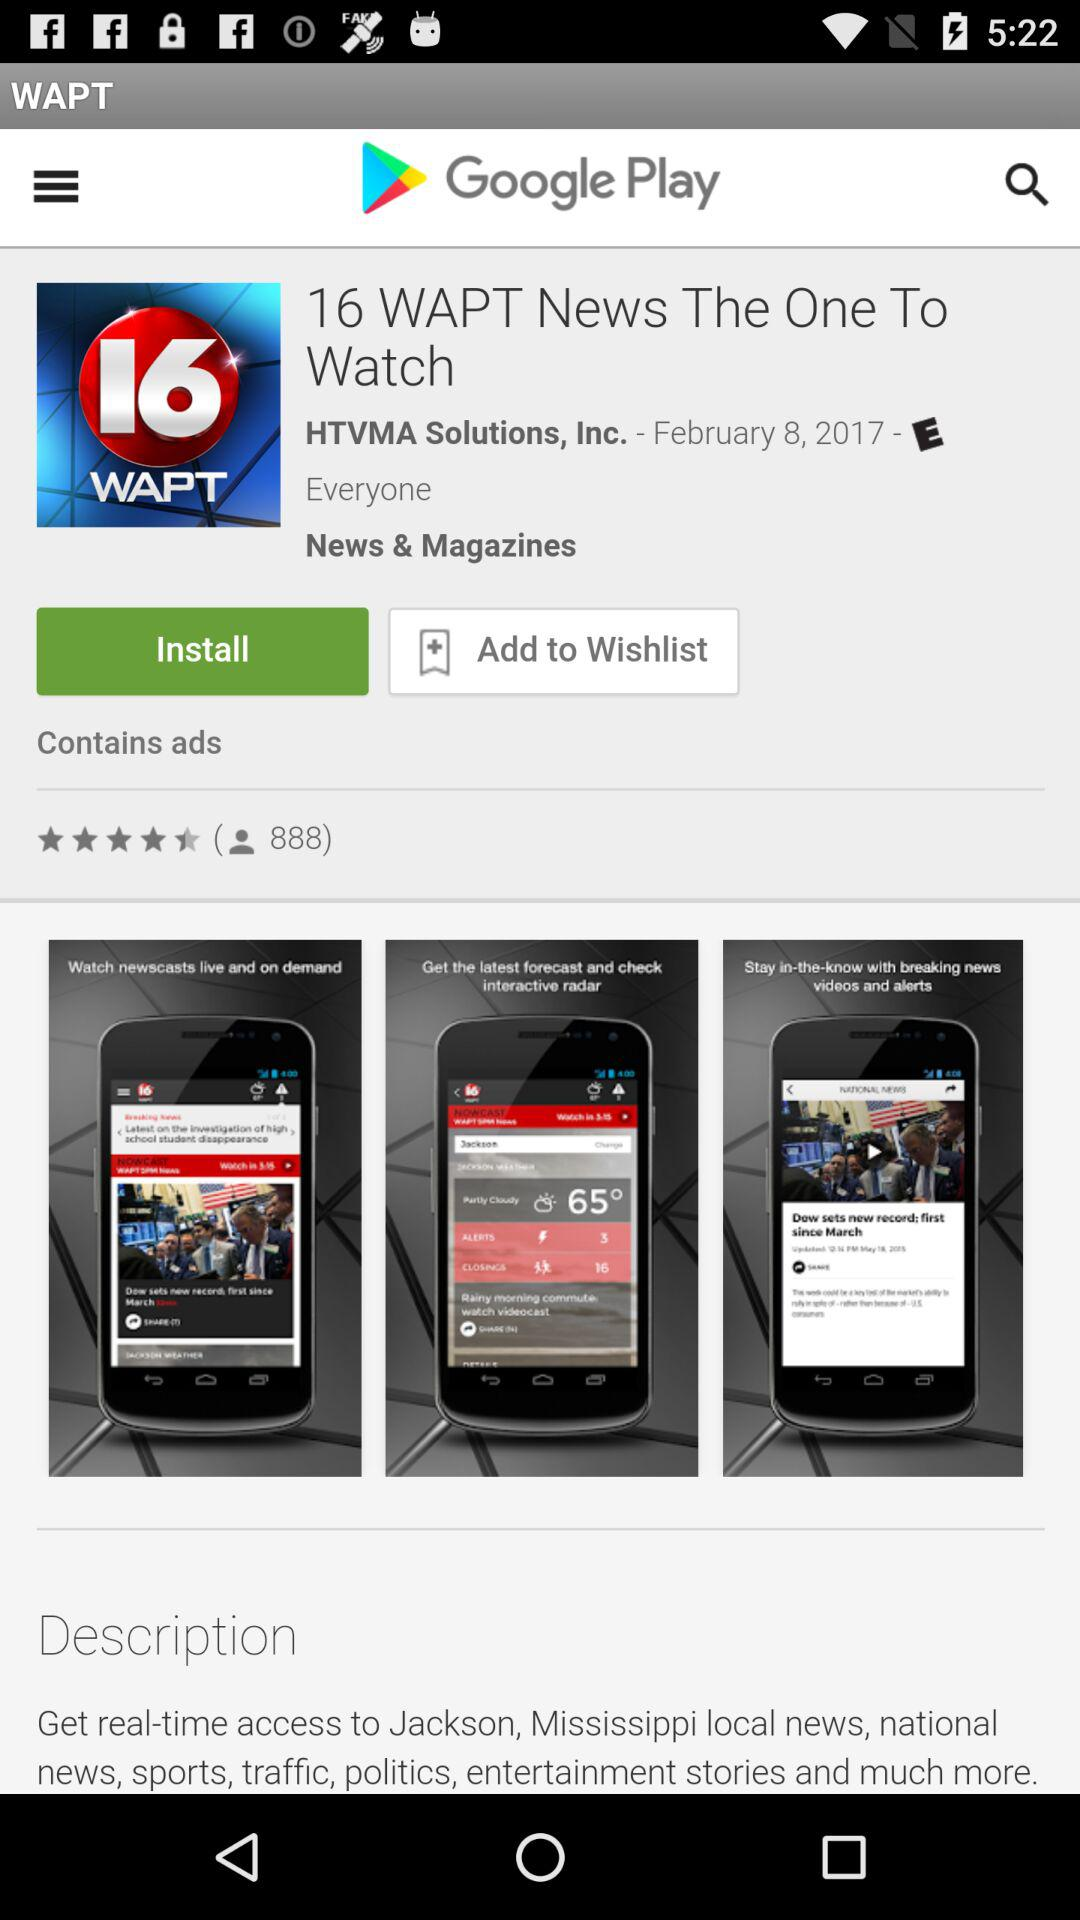What's the total number of reviewers? The total number of reviewers is 888. 